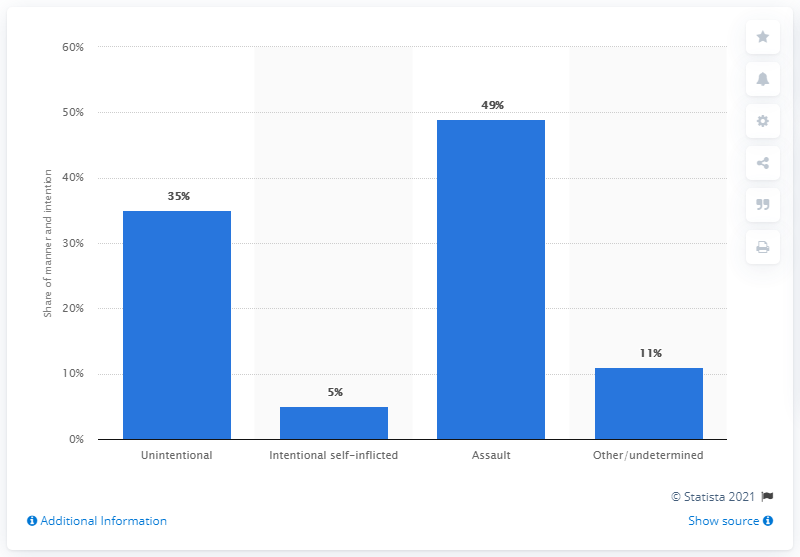Highlight a few significant elements in this photo. In 2009, approximately 49% of emergency department visits were due to assaults. 